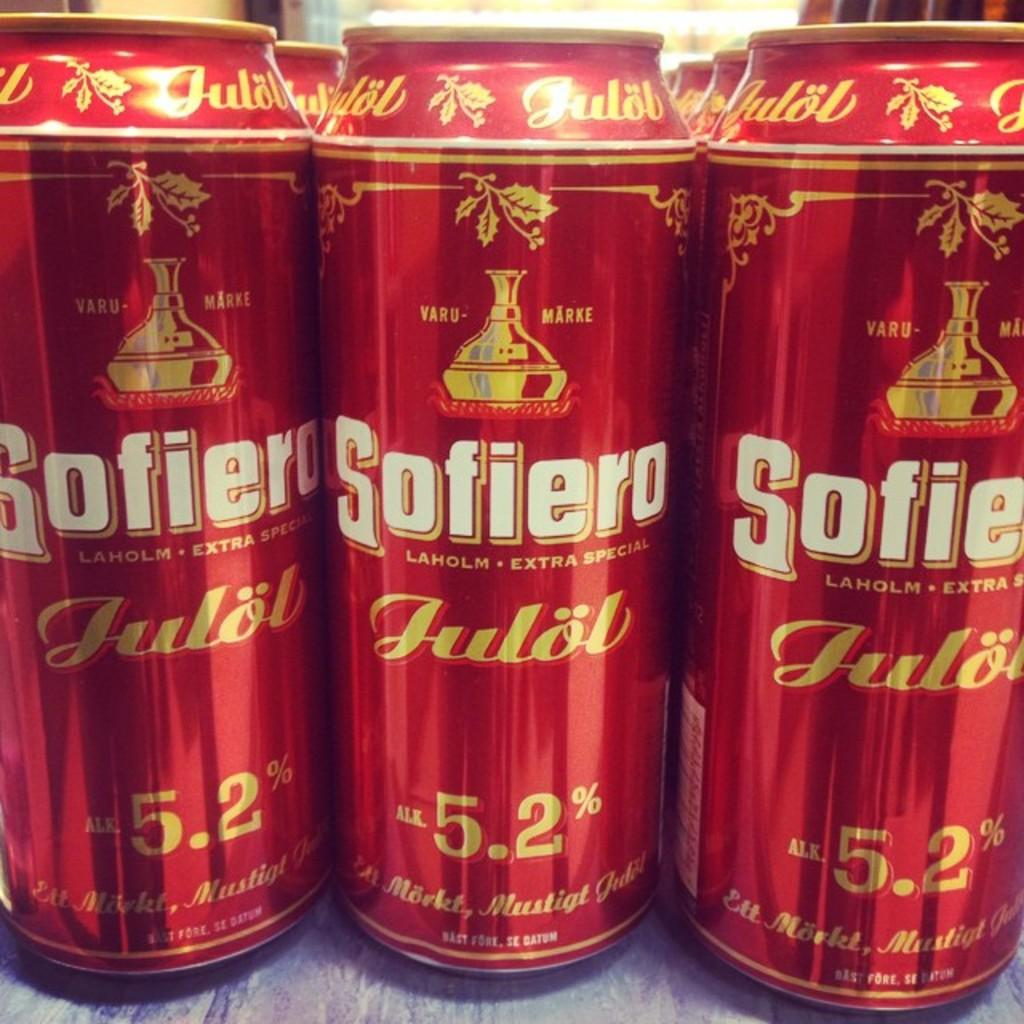<image>
Offer a succinct explanation of the picture presented. The red beer shown is 5.2% and called Sofiero. 